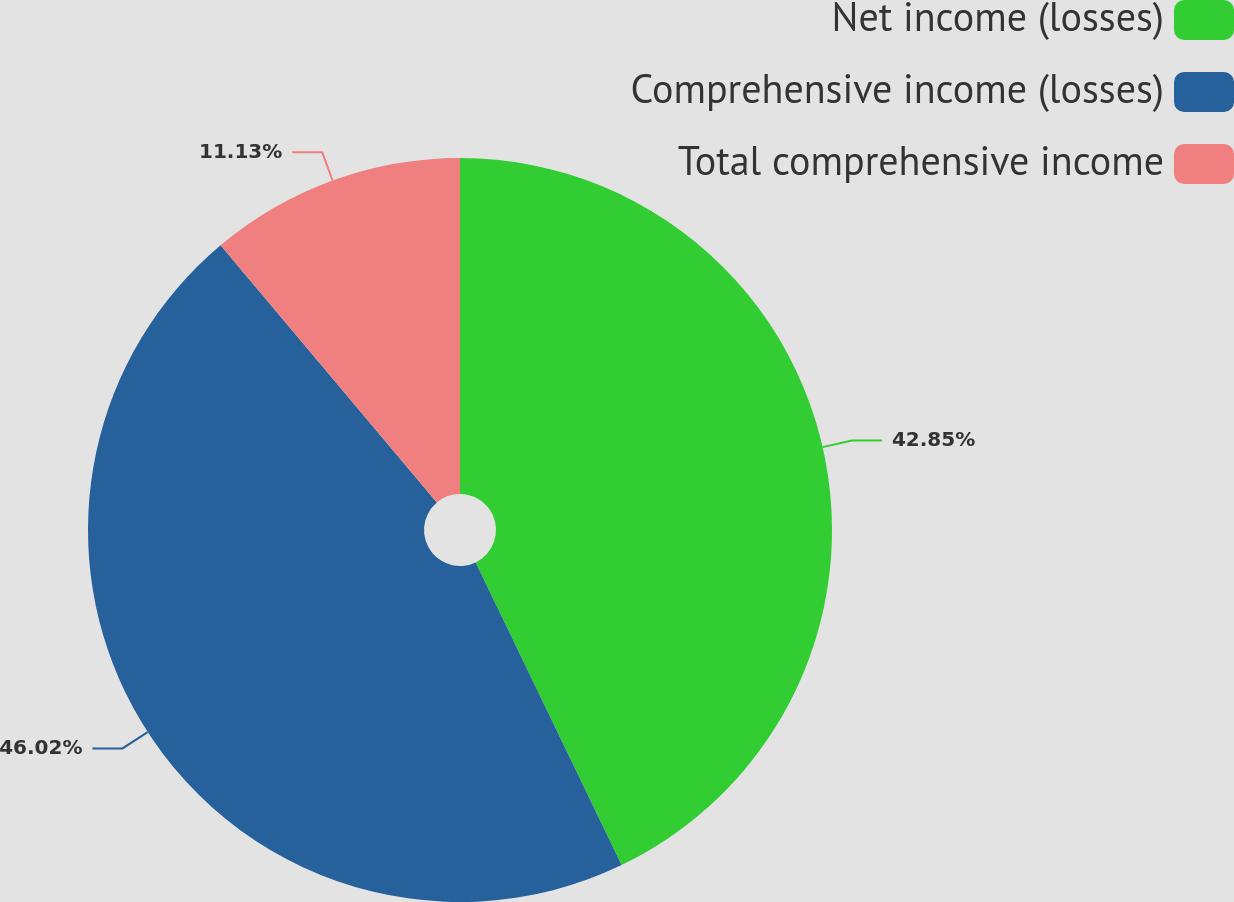<chart> <loc_0><loc_0><loc_500><loc_500><pie_chart><fcel>Net income (losses)<fcel>Comprehensive income (losses)<fcel>Total comprehensive income<nl><fcel>42.85%<fcel>46.02%<fcel>11.13%<nl></chart> 